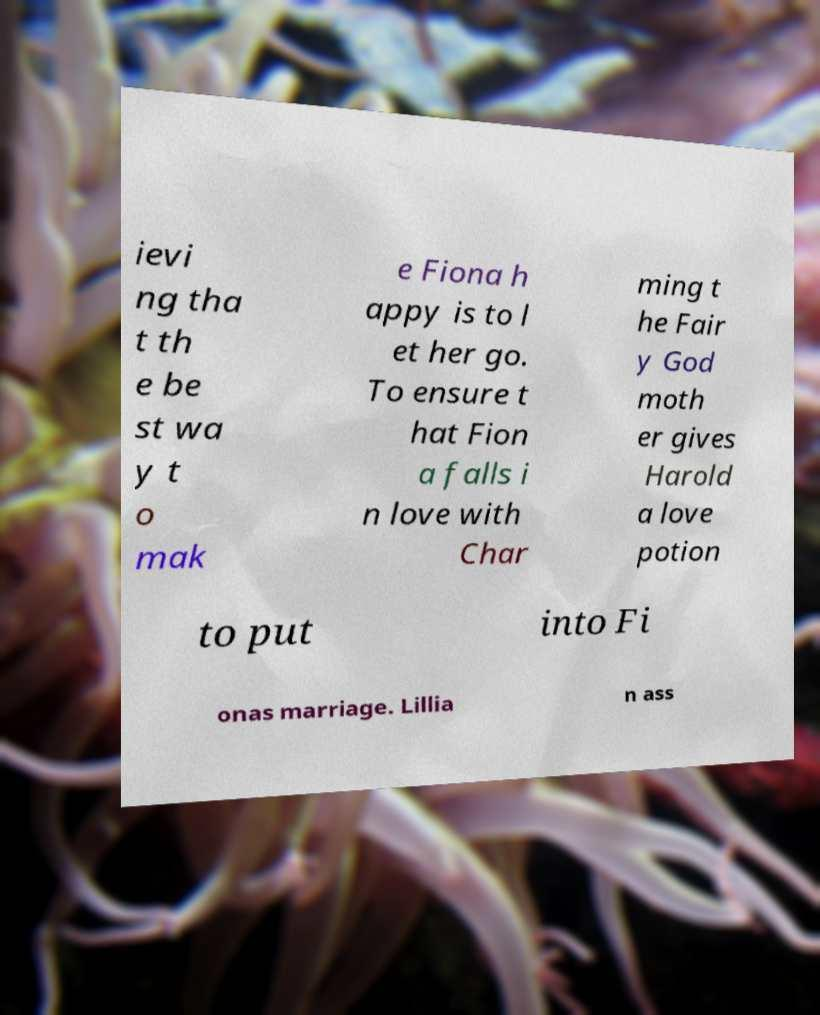What messages or text are displayed in this image? I need them in a readable, typed format. ievi ng tha t th e be st wa y t o mak e Fiona h appy is to l et her go. To ensure t hat Fion a falls i n love with Char ming t he Fair y God moth er gives Harold a love potion to put into Fi onas marriage. Lillia n ass 